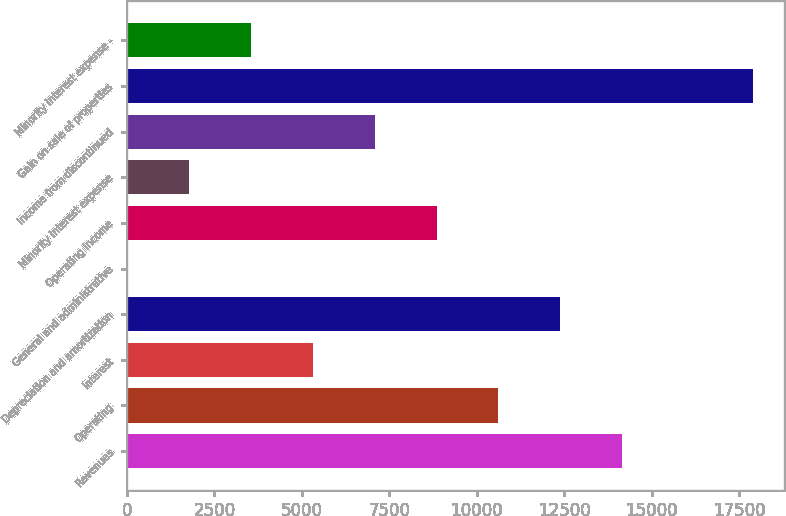Convert chart to OTSL. <chart><loc_0><loc_0><loc_500><loc_500><bar_chart><fcel>Revenues<fcel>Operating<fcel>Interest<fcel>Depreciation and amortization<fcel>General and administrative<fcel>Operating Income<fcel>Minority interest expense<fcel>Income from discontinued<fcel>Gain on sale of properties<fcel>Minority interest expense -<nl><fcel>14158.8<fcel>10619.6<fcel>5310.8<fcel>12389.2<fcel>2<fcel>8850<fcel>1771.6<fcel>7080.4<fcel>17894.6<fcel>3541.2<nl></chart> 